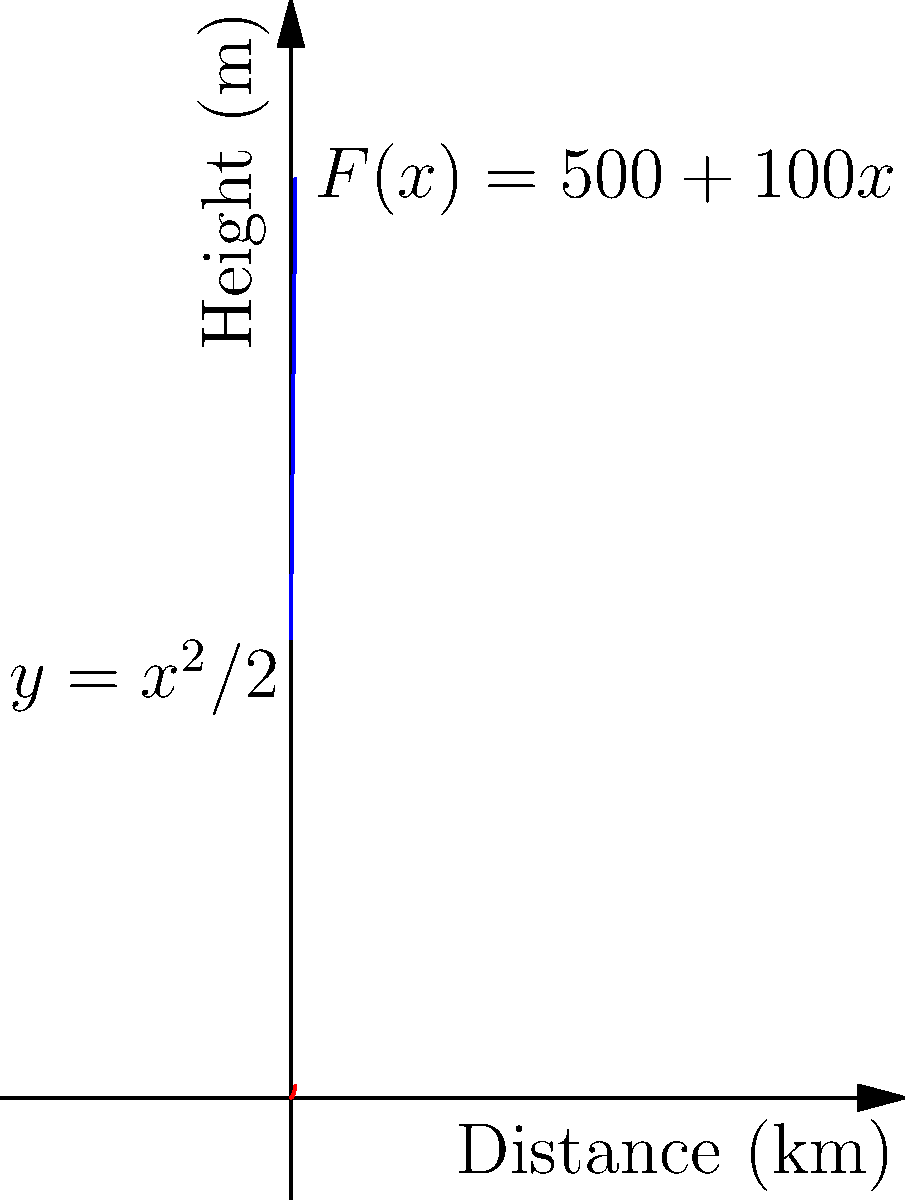A trekker is climbing a steep trail in the Western Ghats near Bangalore. The path can be modeled by the function $y = \frac{x^2}{2}$, where $y$ is the height in meters and $x$ is the horizontal distance in kilometers. The force required to climb (in Newtons) is given by $F(x) = 500 + 100x$. Calculate the work done by the trekker to climb from the base $(0,0)$ to the point $(5,12.5)$ on the trail. To solve this problem, we'll use the work integral formula:

$$W = \int_a^b F(x) \cdot \frac{dy}{dx} dx$$

Step 1: Find $\frac{dy}{dx}$
$$y = \frac{x^2}{2}$$
$$\frac{dy}{dx} = x$$

Step 2: Set up the integral
$$W = \int_0^5 (500 + 100x) \cdot x \, dx$$

Step 3: Expand the integrand
$$W = \int_0^5 (500x + 100x^2) \, dx$$

Step 4: Integrate
$$W = \left[ 250x^2 + \frac{100}{3}x^3 \right]_0^5$$

Step 5: Evaluate the integral
$$W = \left( 250(5^2) + \frac{100}{3}(5^3) \right) - \left( 250(0^2) + \frac{100}{3}(0^3) \right)$$
$$W = \left( 6250 + 4166.67 \right) - 0$$
$$W = 10416.67$$

Step 6: Round to a reasonable number of significant figures and add units
$$W \approx 10,400 \text{ J}$$
Answer: 10,400 J 